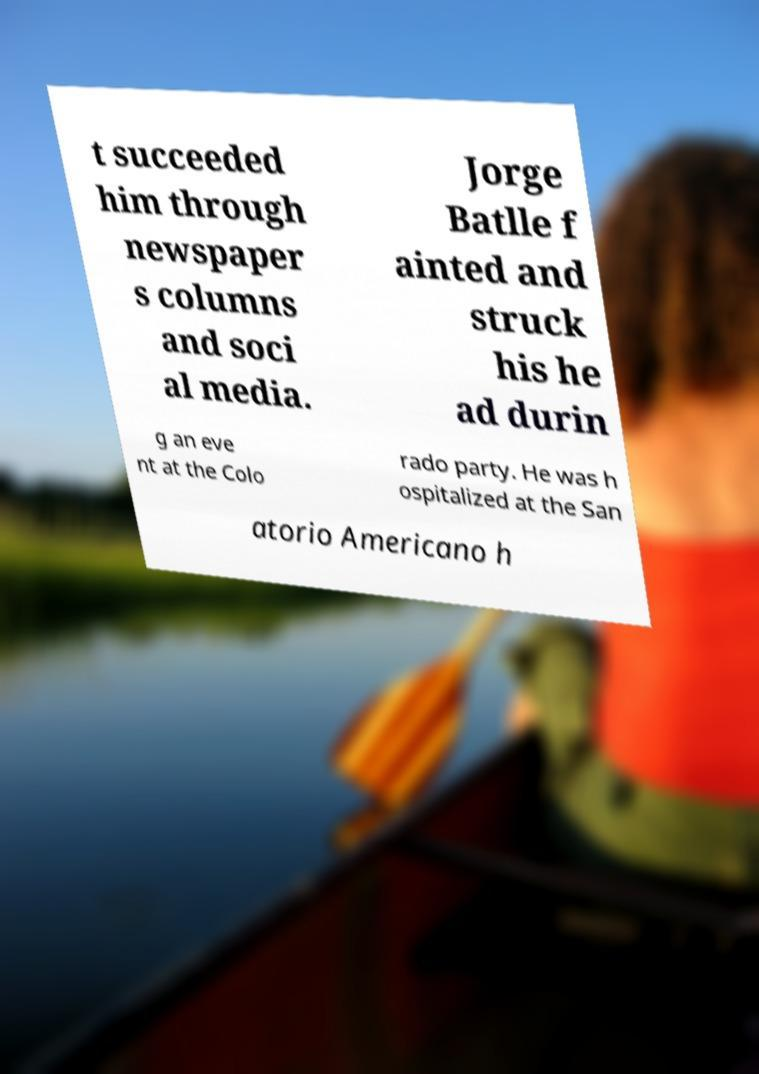Could you assist in decoding the text presented in this image and type it out clearly? t succeeded him through newspaper s columns and soci al media. Jorge Batlle f ainted and struck his he ad durin g an eve nt at the Colo rado party. He was h ospitalized at the San atorio Americano h 